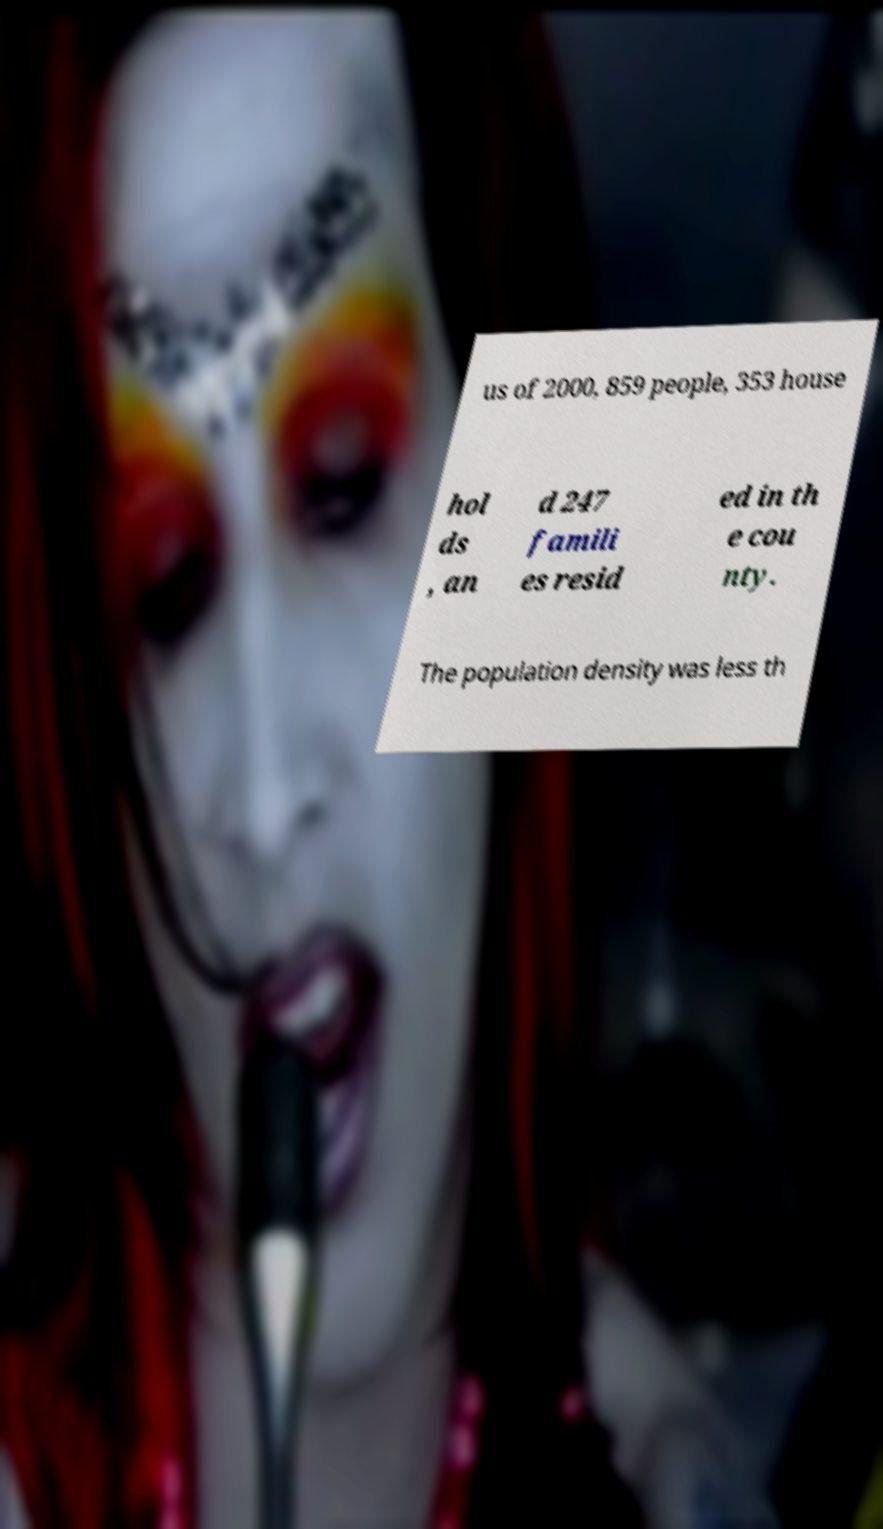There's text embedded in this image that I need extracted. Can you transcribe it verbatim? us of 2000, 859 people, 353 house hol ds , an d 247 famili es resid ed in th e cou nty. The population density was less th 